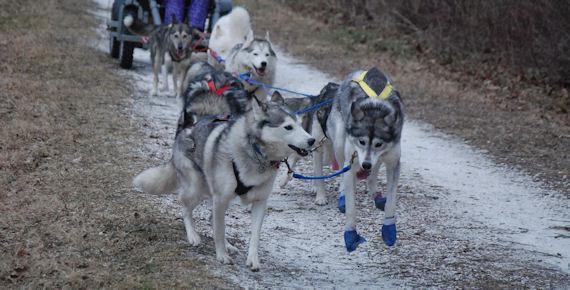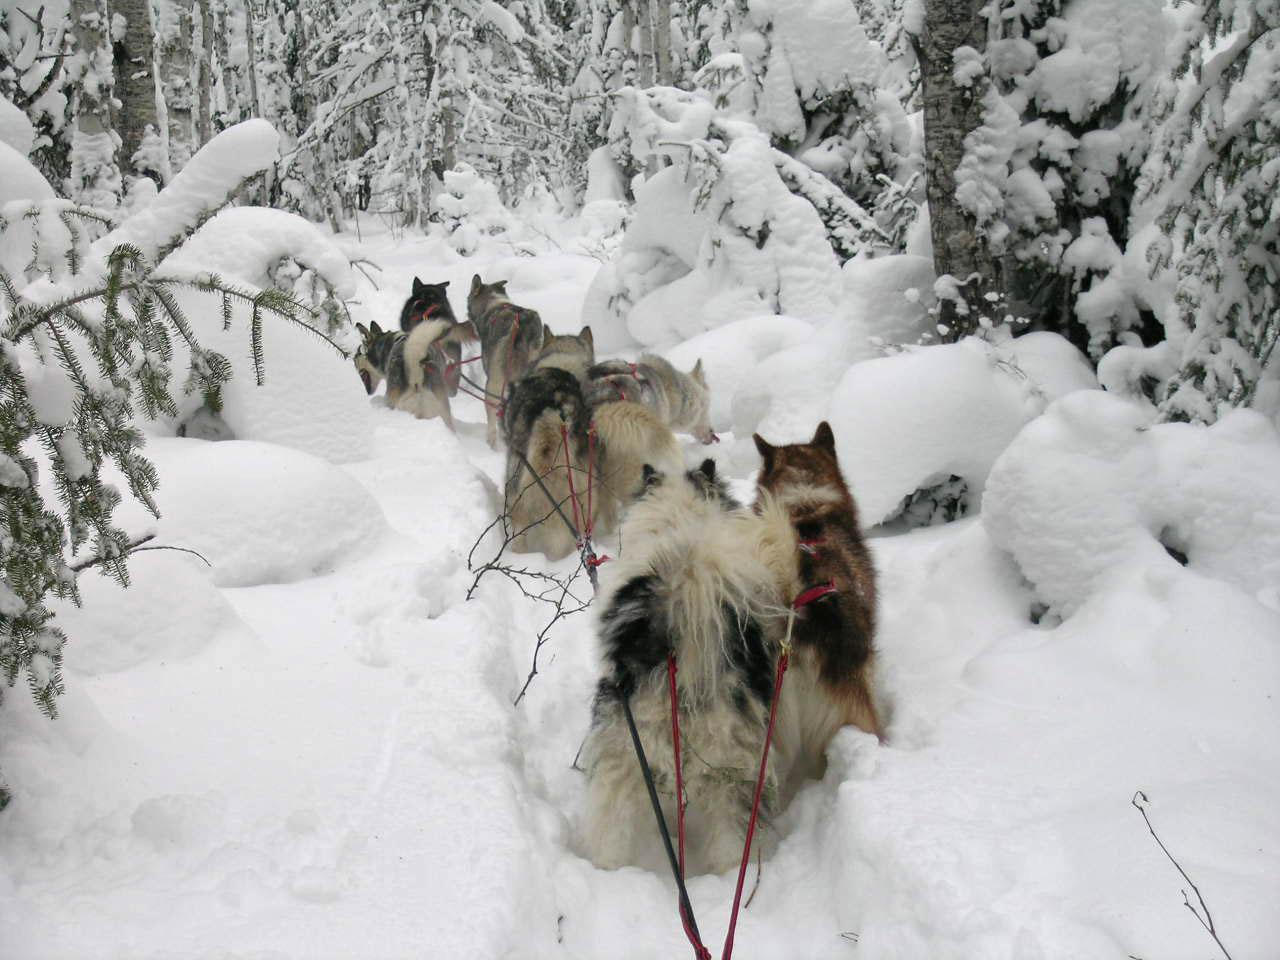The first image is the image on the left, the second image is the image on the right. Examine the images to the left and right. Is the description "The person on the sled in the image on the right is wearing a red jacket." accurate? Answer yes or no. No. The first image is the image on the left, the second image is the image on the right. Considering the images on both sides, is "A figure in red outerwear stands behind a rightward-angled sled with no passenger, pulled by at least one dog figure." valid? Answer yes or no. No. 